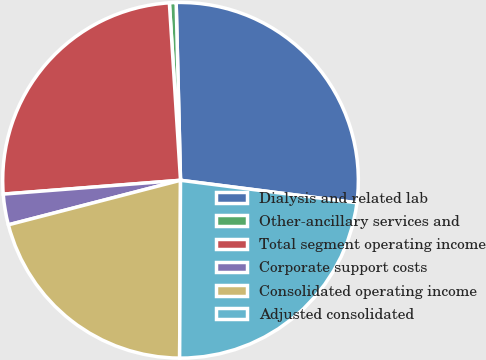<chart> <loc_0><loc_0><loc_500><loc_500><pie_chart><fcel>Dialysis and related lab<fcel>Other-ancillary services and<fcel>Total segment operating income<fcel>Corporate support costs<fcel>Consolidated operating income<fcel>Adjusted consolidated<nl><fcel>27.41%<fcel>0.61%<fcel>25.24%<fcel>2.79%<fcel>20.89%<fcel>23.06%<nl></chart> 